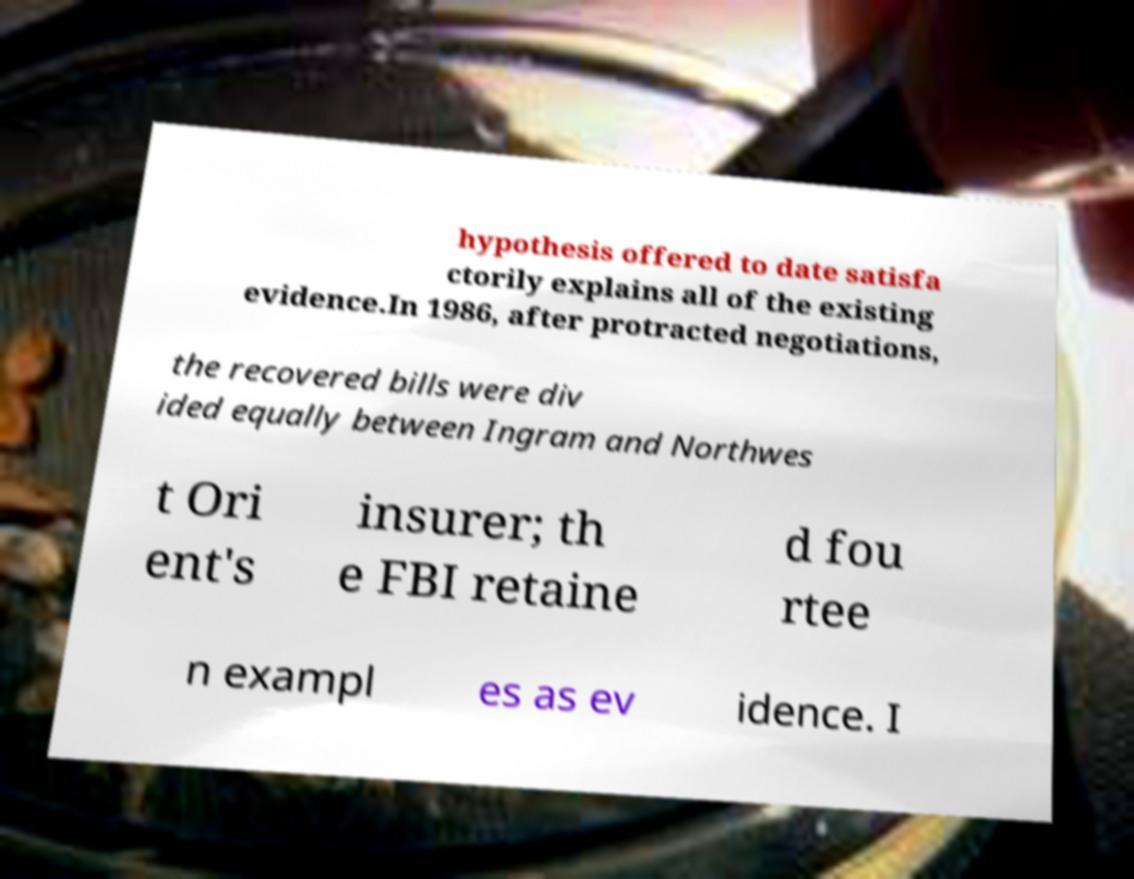Could you extract and type out the text from this image? hypothesis offered to date satisfa ctorily explains all of the existing evidence.In 1986, after protracted negotiations, the recovered bills were div ided equally between Ingram and Northwes t Ori ent's insurer; th e FBI retaine d fou rtee n exampl es as ev idence. I 